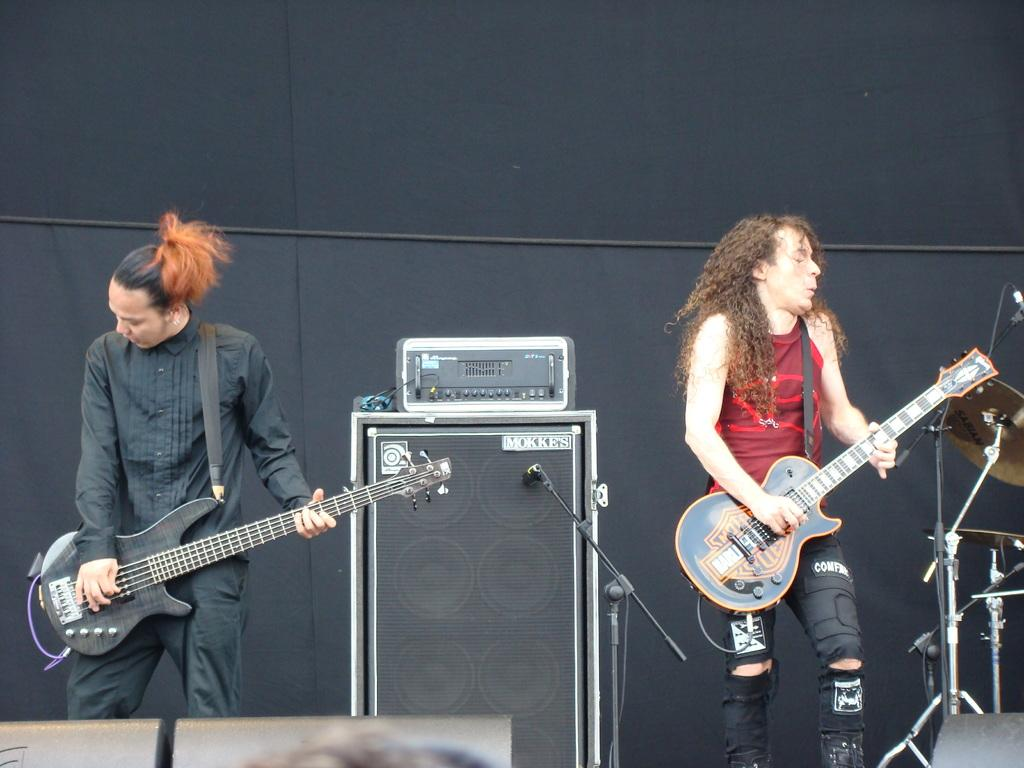Who is present in the image? There is a man and a woman in the image. What are they doing in the image? The man and woman are playing guitar in the image. Where are they performing this activity? They are on a stage in the image. What type of throat lozenges can be seen on the shelf behind the musicians? There is no shelf or throat lozenges present in the image. 